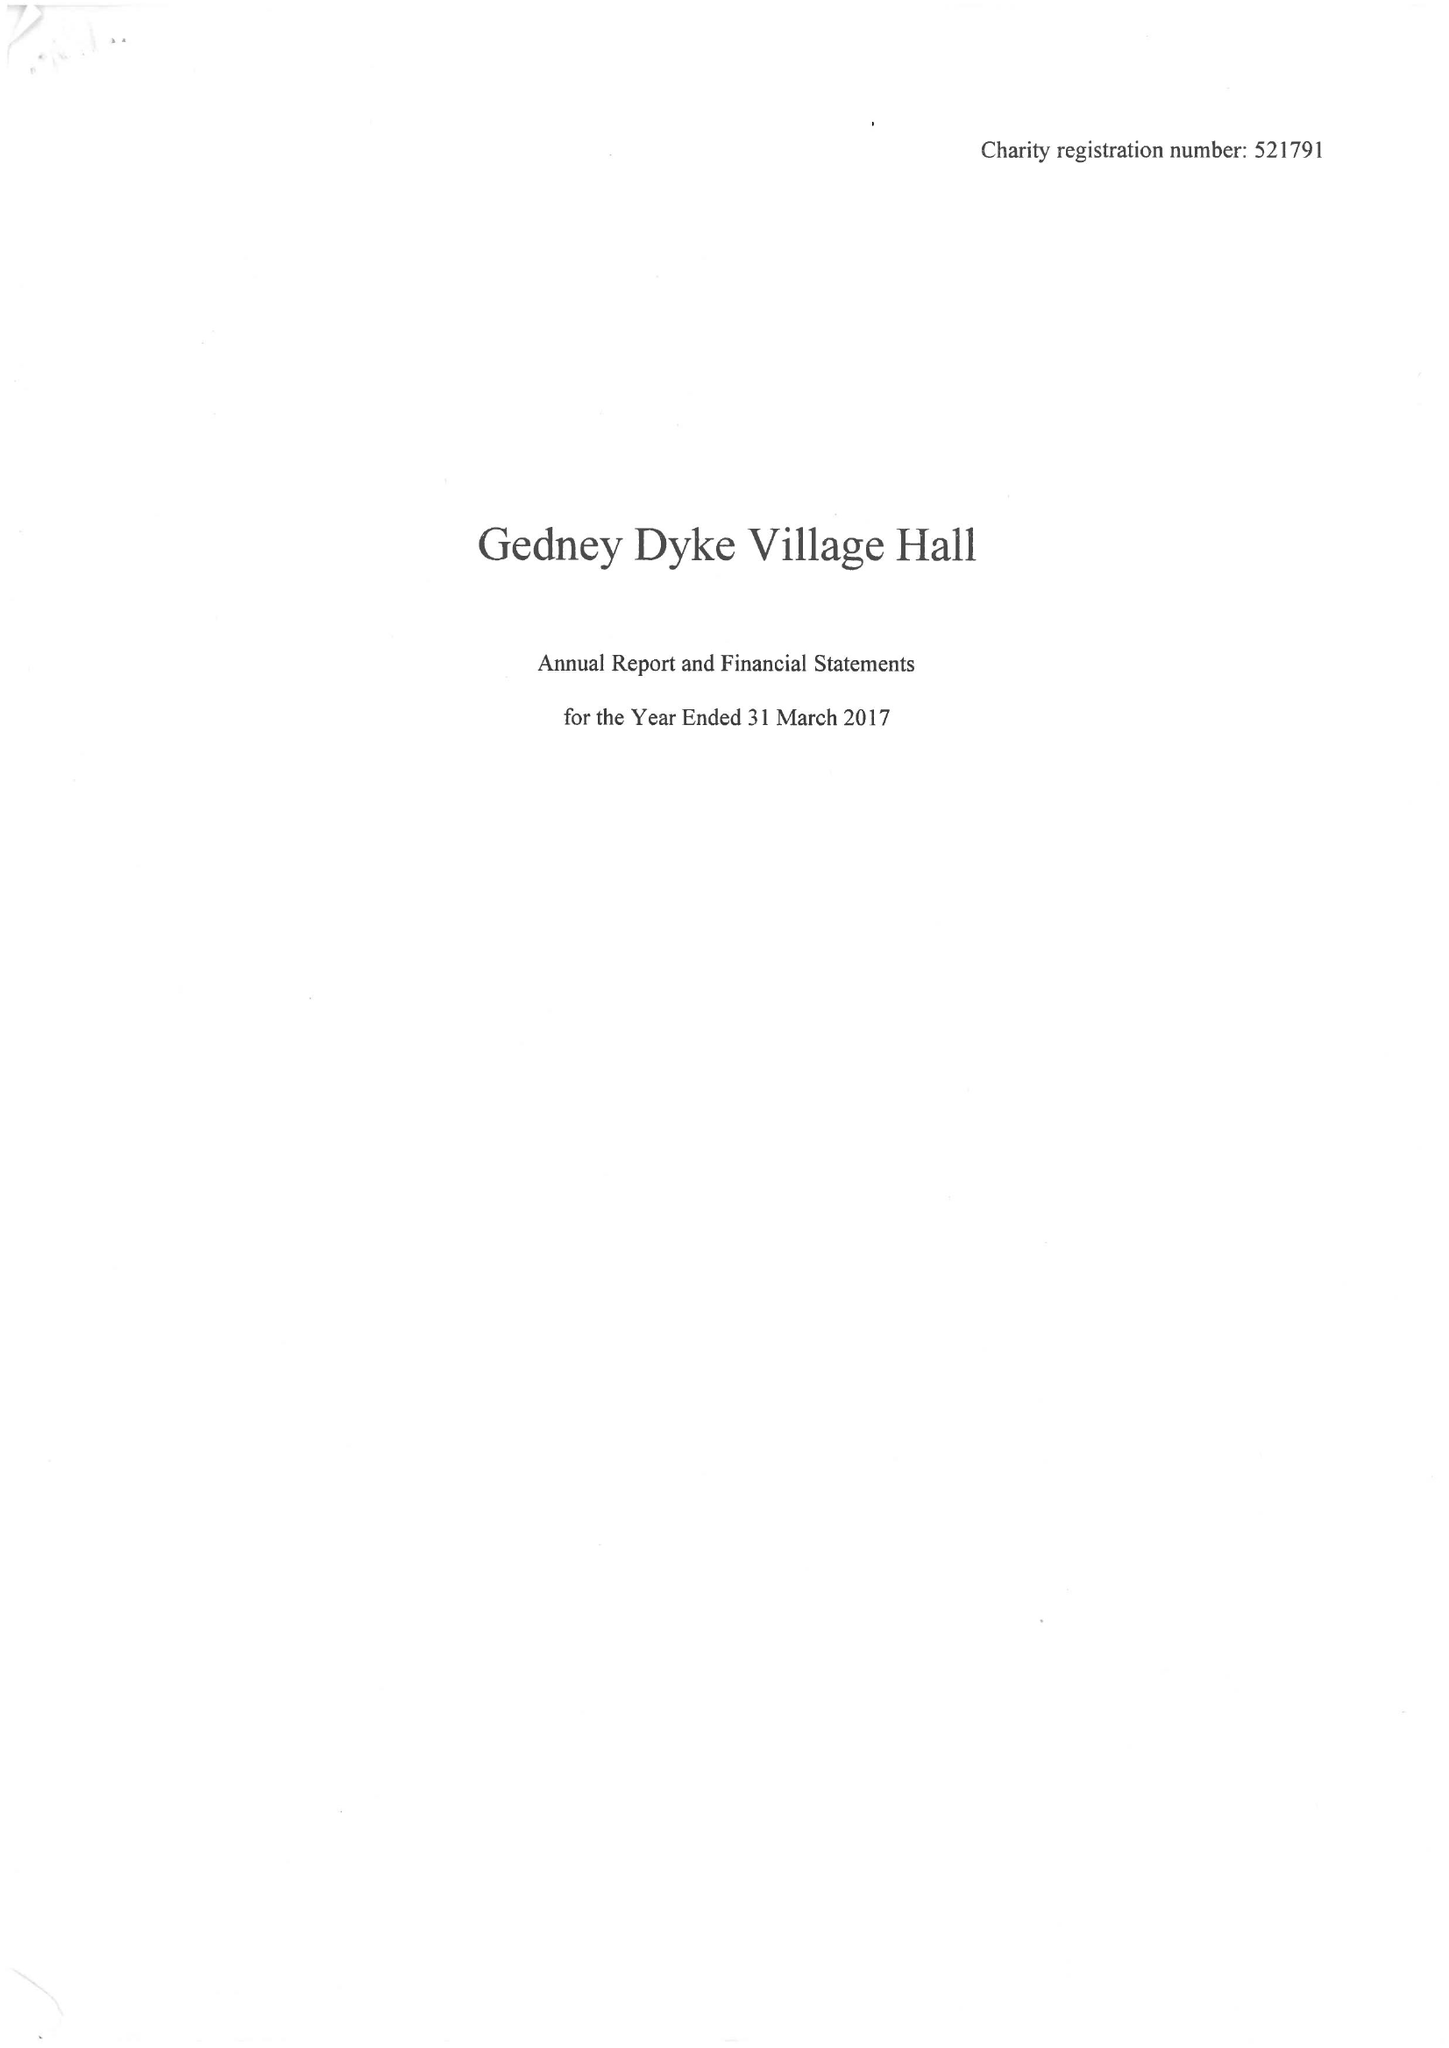What is the value for the address__post_town?
Answer the question using a single word or phrase. SPALDING 